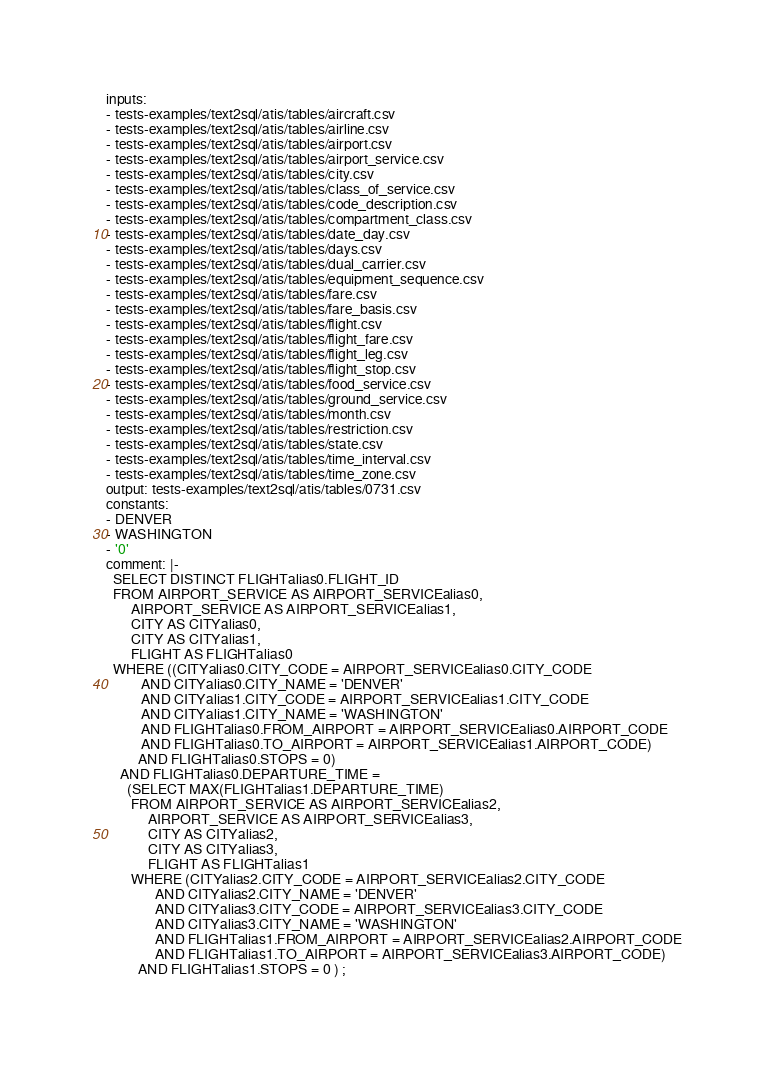<code> <loc_0><loc_0><loc_500><loc_500><_YAML_>inputs:
- tests-examples/text2sql/atis/tables/aircraft.csv
- tests-examples/text2sql/atis/tables/airline.csv
- tests-examples/text2sql/atis/tables/airport.csv
- tests-examples/text2sql/atis/tables/airport_service.csv
- tests-examples/text2sql/atis/tables/city.csv
- tests-examples/text2sql/atis/tables/class_of_service.csv
- tests-examples/text2sql/atis/tables/code_description.csv
- tests-examples/text2sql/atis/tables/compartment_class.csv
- tests-examples/text2sql/atis/tables/date_day.csv
- tests-examples/text2sql/atis/tables/days.csv
- tests-examples/text2sql/atis/tables/dual_carrier.csv
- tests-examples/text2sql/atis/tables/equipment_sequence.csv
- tests-examples/text2sql/atis/tables/fare.csv
- tests-examples/text2sql/atis/tables/fare_basis.csv
- tests-examples/text2sql/atis/tables/flight.csv
- tests-examples/text2sql/atis/tables/flight_fare.csv
- tests-examples/text2sql/atis/tables/flight_leg.csv
- tests-examples/text2sql/atis/tables/flight_stop.csv
- tests-examples/text2sql/atis/tables/food_service.csv
- tests-examples/text2sql/atis/tables/ground_service.csv
- tests-examples/text2sql/atis/tables/month.csv
- tests-examples/text2sql/atis/tables/restriction.csv
- tests-examples/text2sql/atis/tables/state.csv
- tests-examples/text2sql/atis/tables/time_interval.csv
- tests-examples/text2sql/atis/tables/time_zone.csv
output: tests-examples/text2sql/atis/tables/0731.csv
constants:
- DENVER
- WASHINGTON
- '0'
comment: |-
  SELECT DISTINCT FLIGHTalias0.FLIGHT_ID
  FROM AIRPORT_SERVICE AS AIRPORT_SERVICEalias0,
       AIRPORT_SERVICE AS AIRPORT_SERVICEalias1,
       CITY AS CITYalias0,
       CITY AS CITYalias1,
       FLIGHT AS FLIGHTalias0
  WHERE ((CITYalias0.CITY_CODE = AIRPORT_SERVICEalias0.CITY_CODE
          AND CITYalias0.CITY_NAME = 'DENVER'
          AND CITYalias1.CITY_CODE = AIRPORT_SERVICEalias1.CITY_CODE
          AND CITYalias1.CITY_NAME = 'WASHINGTON'
          AND FLIGHTalias0.FROM_AIRPORT = AIRPORT_SERVICEalias0.AIRPORT_CODE
          AND FLIGHTalias0.TO_AIRPORT = AIRPORT_SERVICEalias1.AIRPORT_CODE)
         AND FLIGHTalias0.STOPS = 0)
    AND FLIGHTalias0.DEPARTURE_TIME =
      (SELECT MAX(FLIGHTalias1.DEPARTURE_TIME)
       FROM AIRPORT_SERVICE AS AIRPORT_SERVICEalias2,
            AIRPORT_SERVICE AS AIRPORT_SERVICEalias3,
            CITY AS CITYalias2,
            CITY AS CITYalias3,
            FLIGHT AS FLIGHTalias1
       WHERE (CITYalias2.CITY_CODE = AIRPORT_SERVICEalias2.CITY_CODE
              AND CITYalias2.CITY_NAME = 'DENVER'
              AND CITYalias3.CITY_CODE = AIRPORT_SERVICEalias3.CITY_CODE
              AND CITYalias3.CITY_NAME = 'WASHINGTON'
              AND FLIGHTalias1.FROM_AIRPORT = AIRPORT_SERVICEalias2.AIRPORT_CODE
              AND FLIGHTalias1.TO_AIRPORT = AIRPORT_SERVICEalias3.AIRPORT_CODE)
         AND FLIGHTalias1.STOPS = 0 ) ;
</code> 